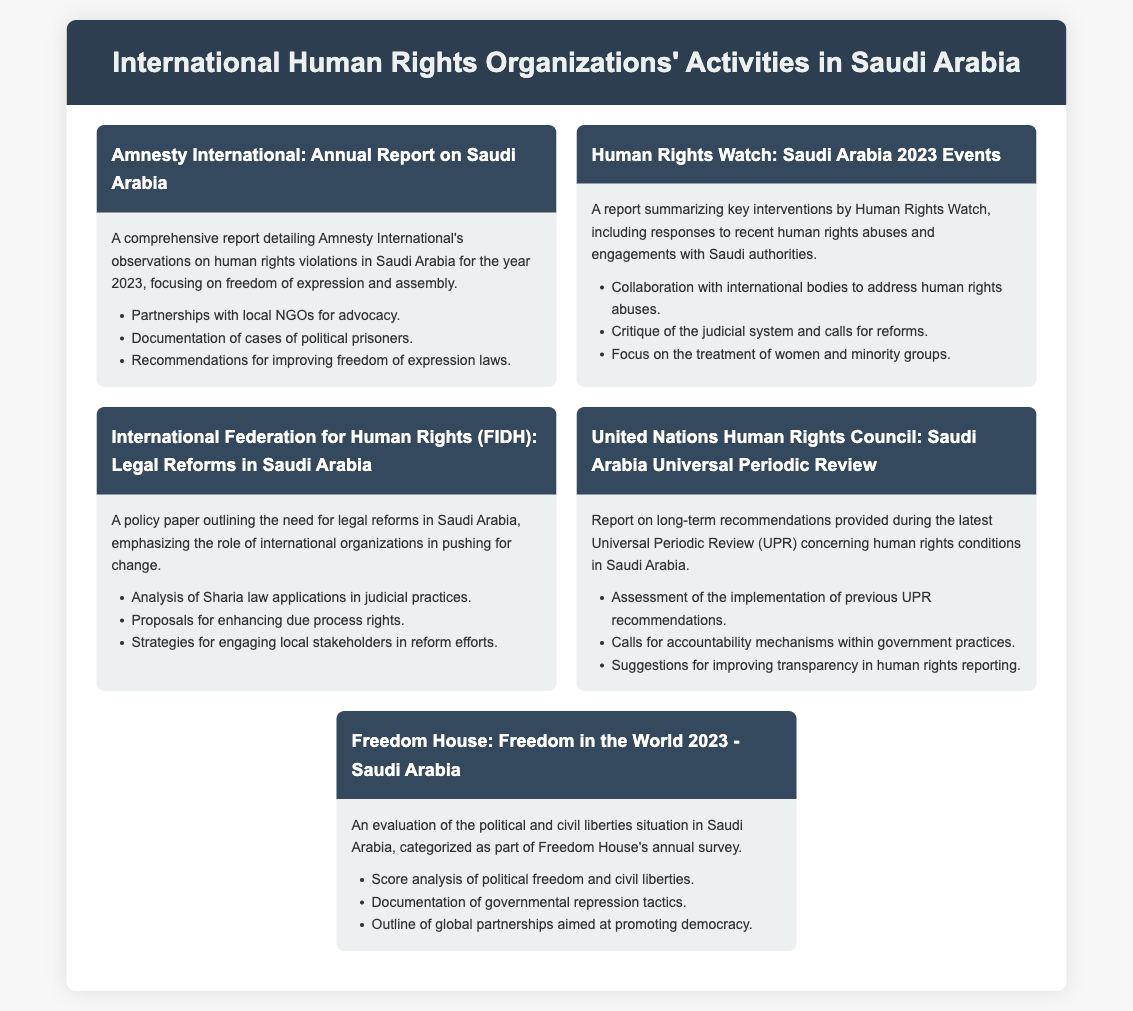What is the title of the report by Amnesty International? The title is stated in the document as "Annual Report on Saudi Arabia".
Answer: Annual Report on Saudi Arabia What year does the Amnesty International report focus on? The document specifies the year that Amnesty International's report covers, which is 2023.
Answer: 2023 Which organization critiqued the judicial system? The report by Human Rights Watch discusses the critique of the judicial system.
Answer: Human Rights Watch What is one of the recommendations from Amnesty International? One of the recommendations includes improving freedom of expression laws according to the document.
Answer: Improving freedom of expression laws How many organizations are mentioned in the document? The document lists a total of five international human rights organizations active in Saudi Arabia.
Answer: Five What type of document is this? The document is a menu showcasing various reports on human rights organizations' activities.
Answer: Menu What is highlighted in the report by FIDH? The report emphasizes the need for legal reforms in Saudi Arabia.
Answer: Legal reforms Which group reported on the Universal Periodic Review? The report concerns the Universal Periodic Review, which is addressed by the United Nations Human Rights Council.
Answer: United Nations Human Rights Council What aspect of women's rights is addressed? The focus on the treatment of women is mentioned in the Human Rights Watch report.
Answer: Treatment of women 